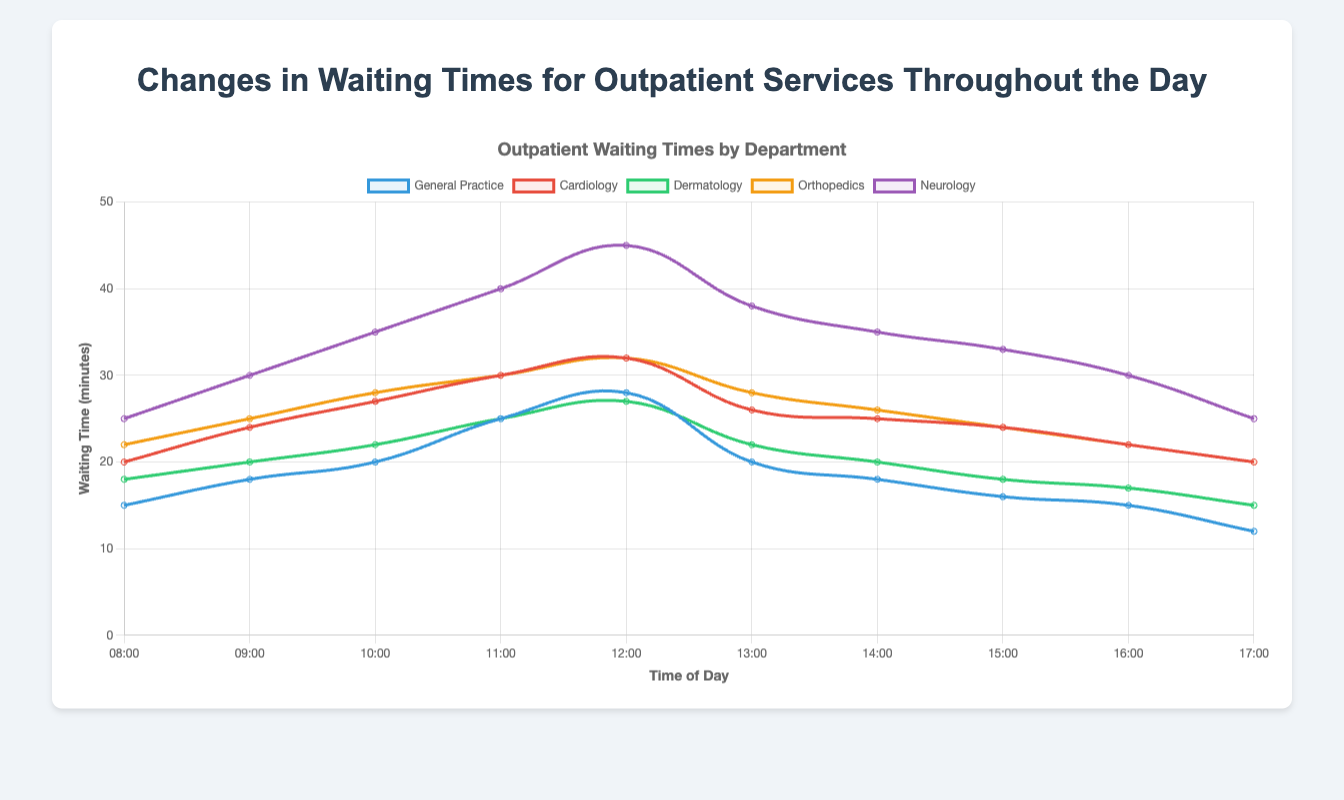What is the trend of waiting times for General Practice throughout the day? To determine the trend of waiting times for General Practice, follow the curve representing General Practice (in blue). It starts at 15 minutes at 08:00, increases to a peak of 28 at 12:00, and then gradually decreases to 12 by 17:00, indicating an overall increasing trend till noon followed by a decrease.
Answer: Increasing till noon then decreasing At what time is the waiting time for Neurology the highest? Follow the curve representing Neurology (in purple). It starts at 25 minutes at 08:00, peaks at 45 minutes at 12:00, and then decreases to 25 by 17:00. The highest waiting time is observed at 12:00.
Answer: 12:00 Compare the waiting times for Orthopedics and Dermatology at 11:00. Which has the longer wait time? At 11:00, the waiting time for Orthopedics is represented in orange (30 minutes), while Dermatology is in green (25 minutes). Orthopedics has a longer waiting time.
Answer: Orthopedics What is the waiting time for Cardiology at 08:00 and 14:00? What is the difference between them? At 08:00, the waiting time for Cardiology (in red) is 20 minutes, and at 14:00 it is 25 minutes. The difference between these times is 25 - 20 = 5 minutes.
Answer: 5 minutes Which department has the most significant increase in waiting time from 08:00 to 12:00? Calculate the waiting time increase for each department from 08:00 to 12:00: General Practice (28 - 15 = 13), Cardiology (32 - 20 = 12), Dermatology (27 - 18 = 9), Orthopedics (32 - 22 = 10), Neurology (45 - 25 = 20). Neurology has the most significant increase with 20 minutes.
Answer: Neurology What is the average waiting time for Dermatology throughout the day? Sum the Dermatology waiting times (18 + 20 + 22 + 25 + 27 + 22 + 20 + 18 + 17 + 15) = 204, then calculate the average by dividing by the number of data points (10). 204 / 10 = 20.4 minutes.
Answer: 20.4 minutes Visualize the waiting times for all departments at 10:00 using a y-axis line. Place the departments in descending order. At 10:00, Neurology (35), Orthopedics (28), Cardiology (27), Dermatology (22), General Practice (20). When visualized on a y-axis line, Neurology is the highest, followed by Orthopedics, Cardiology, Dermatology, and General Practice.
Answer: Neurology > Orthopedics > Cardiology > Dermatology > General Practice How does the waiting time for General Practice at 17:00 compare to that at 13:00? At 17:00, the waiting time for General Practice is 12 minutes (in blue), while at 13:00 it is 20 minutes. 12 is less than 20, so the waiting time is shorter at 17:00.
Answer: Less at 17:00 Identify the department that shows the least fluctuation in waiting times throughout the day. Compare the range (difference between max and min) of waiting times: General Practice (28-12=16), Cardiology (32-20=12), Dermatology (27-15=12), Orthopedics (32-20=12), Neurology (45-25=20). Cardiology, Dermatology, and Orthopedics have the least fluctuation with a range of 12 minutes.
Answer: Cardiology, Dermatology, Orthopedics What is the average waiting time increase across all departments from 08:00 to 12:00? Calculate the increase for each department: General Practice (13), Cardiology (12), Dermatology (9), Orthopedics (10), Neurology (20). Sum the increases (13 + 12 + 9 + 10 + 20 = 64). Divide by number of departments (64 / 5 = 12.8).
Answer: 12.8 minutes 